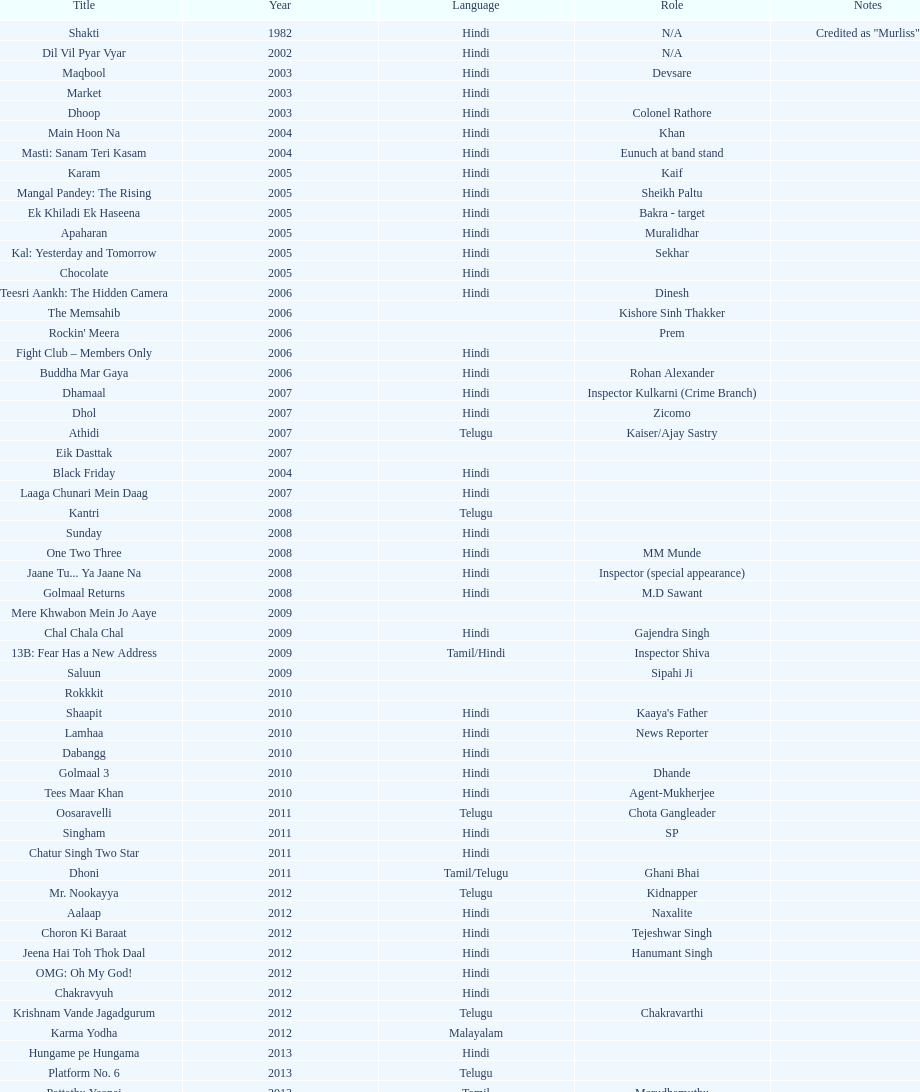What is the most recent malayalam movie featuring this actor? Karma Yodha. 